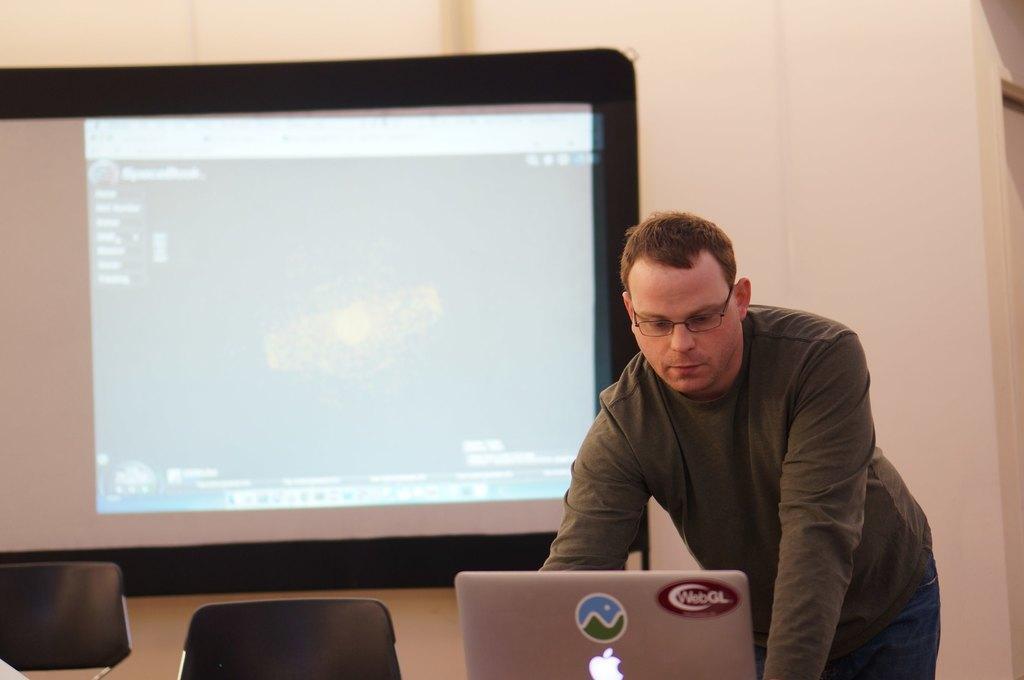Can you describe this image briefly? In this image there is a person standing. He is wearing spectacles. Before him there is a laptop. Left bottom there are two chairs. Behind there is a screen attached to the wall. 